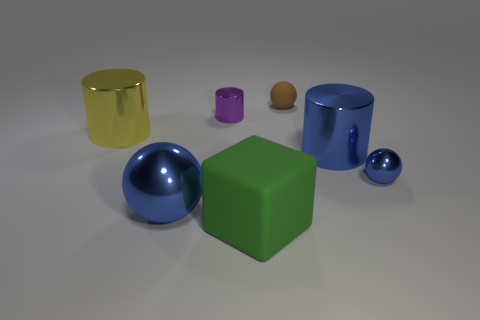Subtract all tiny brown rubber balls. How many balls are left? 2 Add 2 large green rubber cubes. How many objects exist? 9 Subtract all brown blocks. How many blue spheres are left? 2 Subtract all gray spheres. Subtract all cyan cylinders. How many spheres are left? 3 Subtract 0 cyan cylinders. How many objects are left? 7 Subtract all blocks. How many objects are left? 6 Subtract all balls. Subtract all big rubber things. How many objects are left? 3 Add 3 cylinders. How many cylinders are left? 6 Add 4 blue metallic objects. How many blue metallic objects exist? 7 